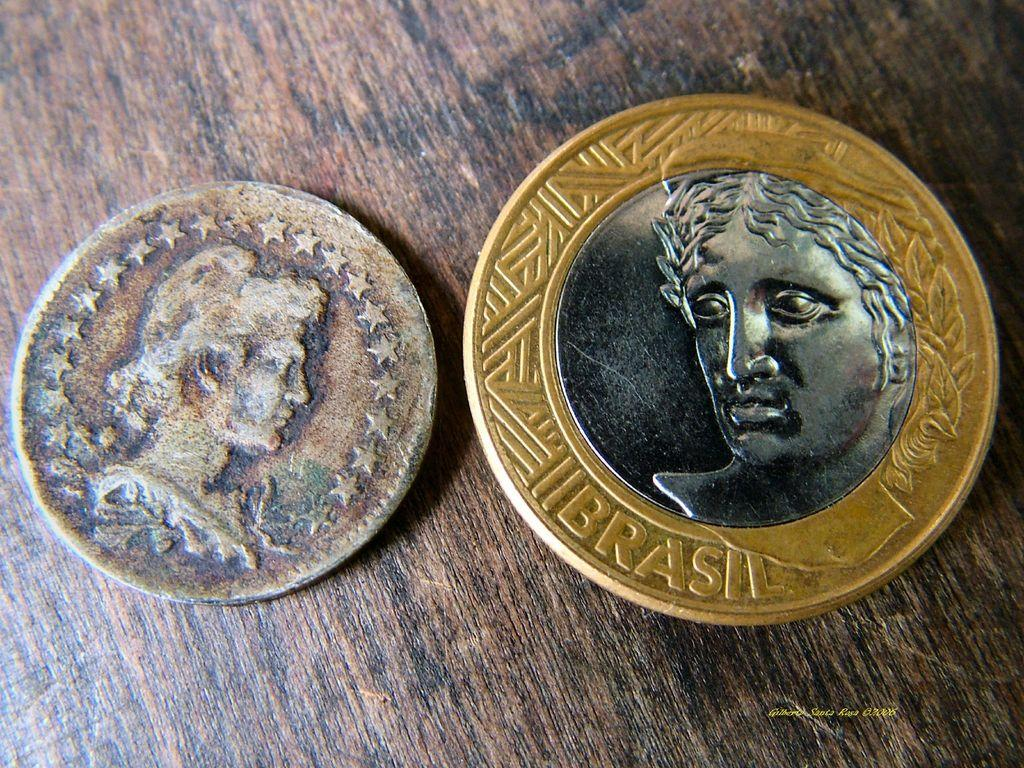Provide a one-sentence caption for the provided image. a couple of coins next to each other with one labeled 'brasil'. 